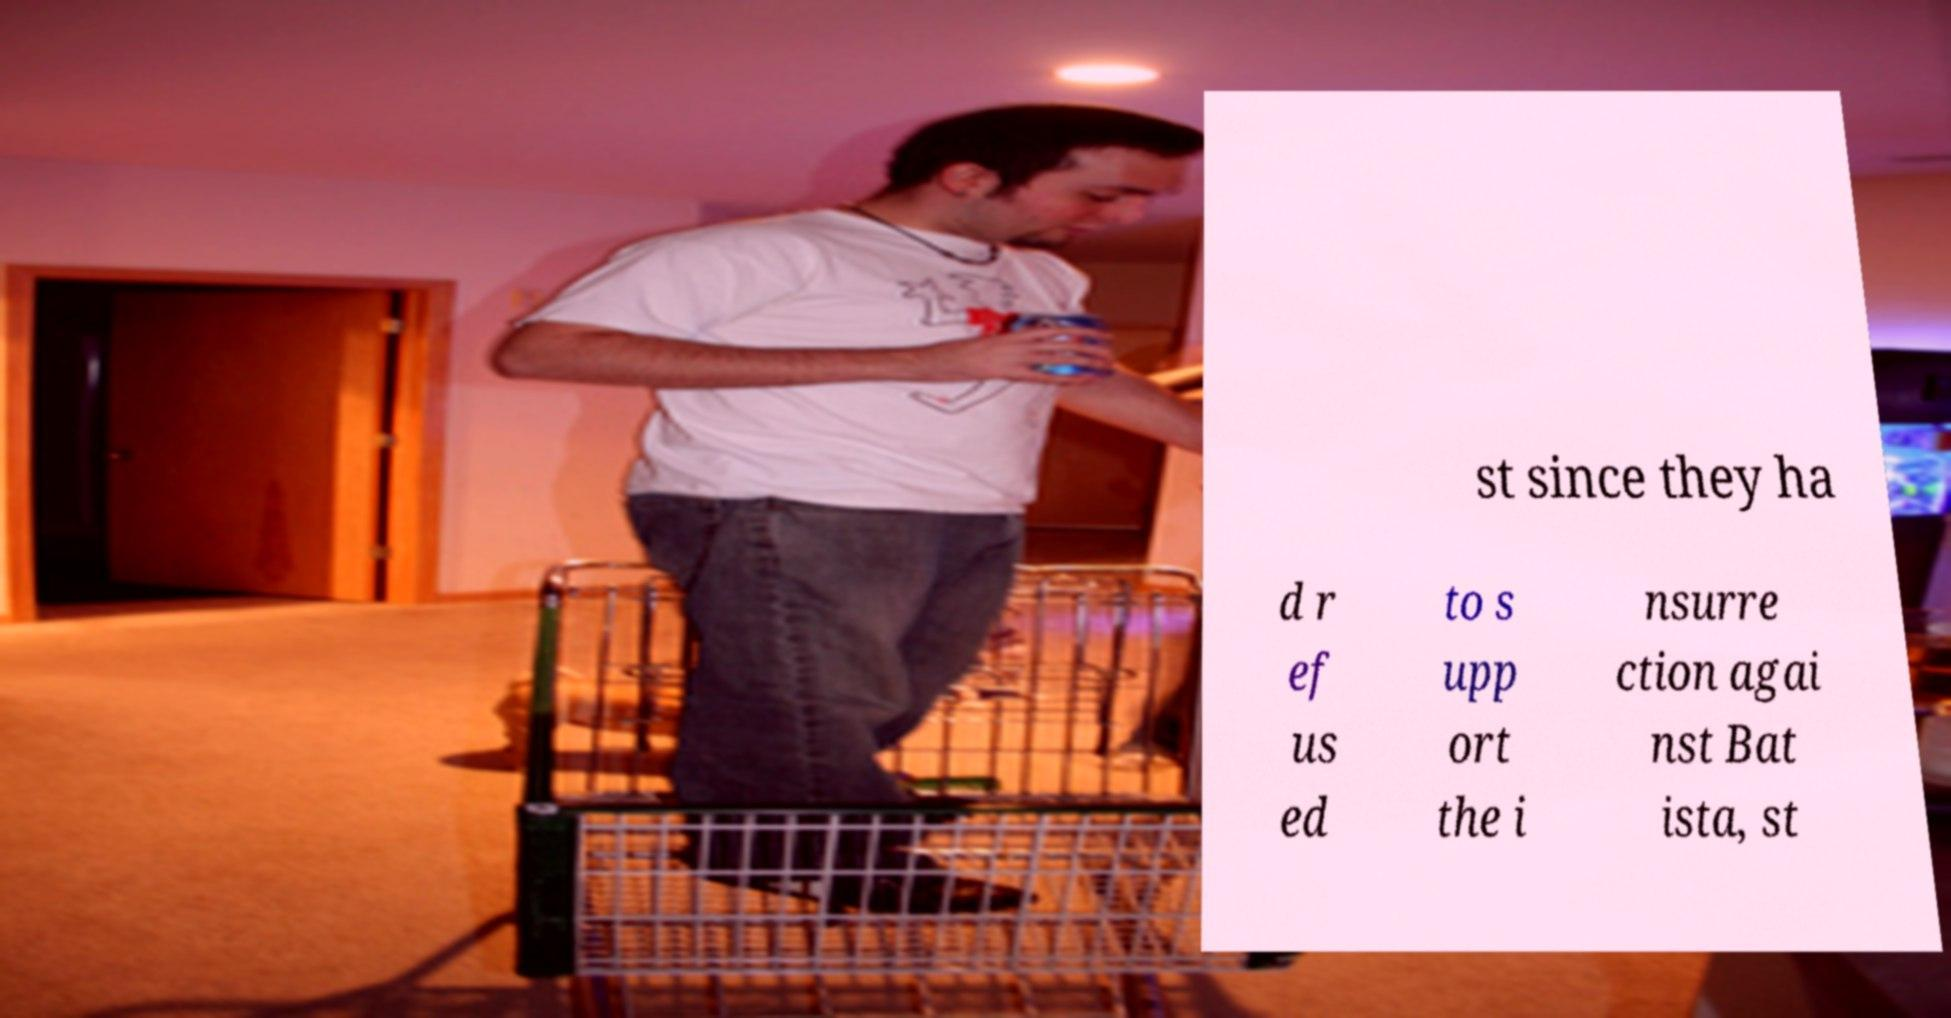What messages or text are displayed in this image? I need them in a readable, typed format. st since they ha d r ef us ed to s upp ort the i nsurre ction agai nst Bat ista, st 